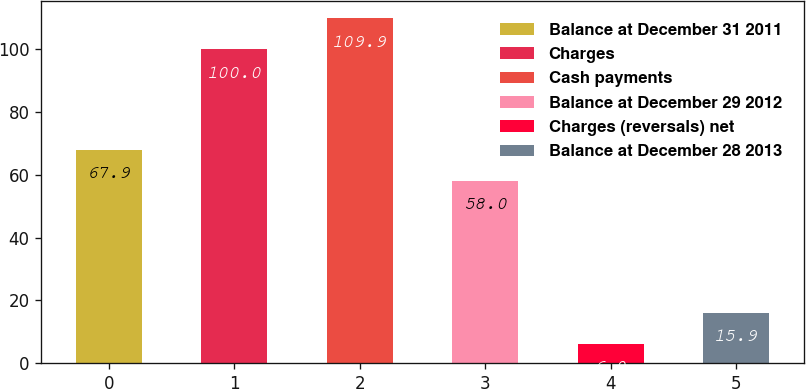<chart> <loc_0><loc_0><loc_500><loc_500><bar_chart><fcel>Balance at December 31 2011<fcel>Charges<fcel>Cash payments<fcel>Balance at December 29 2012<fcel>Charges (reversals) net<fcel>Balance at December 28 2013<nl><fcel>67.9<fcel>100<fcel>109.9<fcel>58<fcel>6<fcel>15.9<nl></chart> 